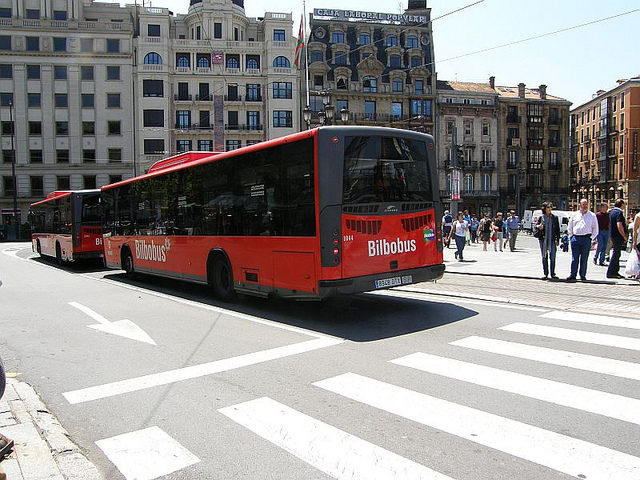Please transcribe the text in this image. Bilbobus Bilbobus 8519 